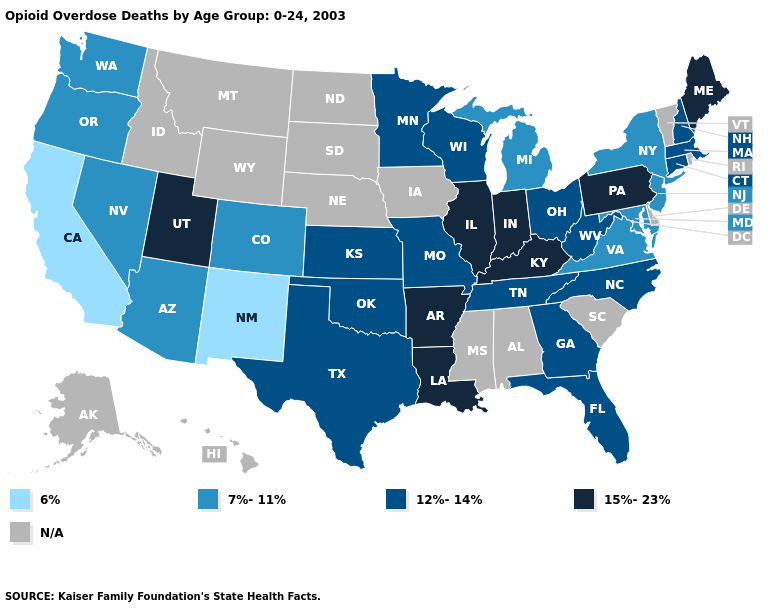Among the states that border Ohio , does Kentucky have the highest value?
Answer briefly. Yes. What is the highest value in states that border Texas?
Answer briefly. 15%-23%. Name the states that have a value in the range 15%-23%?
Write a very short answer. Arkansas, Illinois, Indiana, Kentucky, Louisiana, Maine, Pennsylvania, Utah. Which states hav the highest value in the South?
Short answer required. Arkansas, Kentucky, Louisiana. What is the value of Louisiana?
Short answer required. 15%-23%. What is the value of Kentucky?
Quick response, please. 15%-23%. Among the states that border Delaware , does Maryland have the lowest value?
Quick response, please. Yes. Which states hav the highest value in the South?
Be succinct. Arkansas, Kentucky, Louisiana. Is the legend a continuous bar?
Short answer required. No. What is the value of Ohio?
Concise answer only. 12%-14%. Does Pennsylvania have the highest value in the Northeast?
Answer briefly. Yes. What is the lowest value in the South?
Give a very brief answer. 7%-11%. Among the states that border South Carolina , which have the lowest value?
Quick response, please. Georgia, North Carolina. What is the value of Vermont?
Write a very short answer. N/A. 